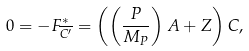<formula> <loc_0><loc_0><loc_500><loc_500>0 = - F _ { \overline { { { C ^ { \prime } } } } } ^ { * } = \left ( \left ( \frac { P } { M _ { P } } \right ) A + Z \right ) C ,</formula> 